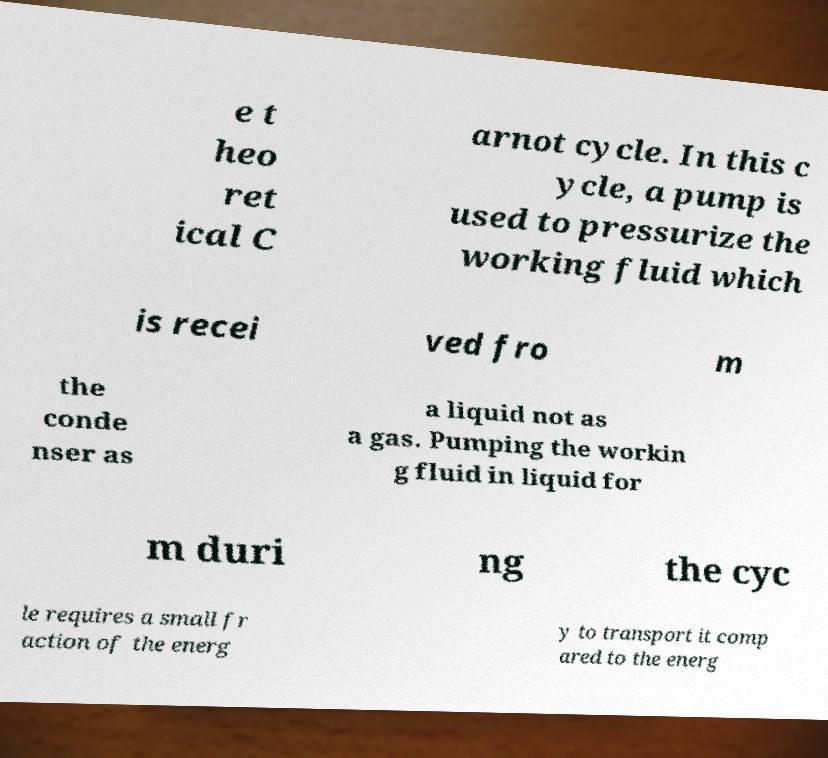Could you extract and type out the text from this image? e t heo ret ical C arnot cycle. In this c ycle, a pump is used to pressurize the working fluid which is recei ved fro m the conde nser as a liquid not as a gas. Pumping the workin g fluid in liquid for m duri ng the cyc le requires a small fr action of the energ y to transport it comp ared to the energ 